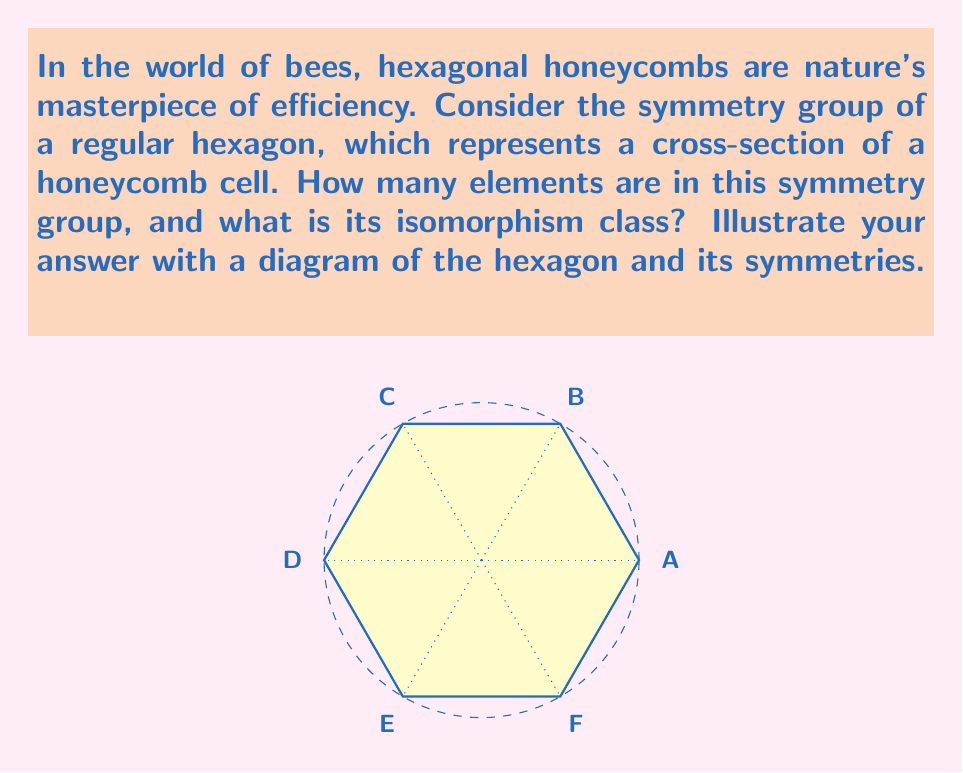Can you solve this math problem? To analyze the symmetry group of a regular hexagon, we need to consider all the transformations that leave the hexagon unchanged. Let's break this down step-by-step:

1) Rotational symmetries:
   - The hexagon can be rotated by 60°, 120°, 180°, 240°, 300°, and 360° (identity).
   - This gives us 6 rotational symmetries.

2) Reflection symmetries:
   - There are 6 lines of reflection: 3 through opposite vertices and 3 through the midpoints of opposite sides.
   - This gives us 6 reflection symmetries.

3) Total number of symmetries:
   - The total number of elements in the symmetry group is the sum of rotational and reflection symmetries.
   - 6 + 6 = 12 elements

4) Group structure:
   - This group is known as the dihedral group of order 12, denoted as $D_6$ or $D_{12}$.
   - It is generated by a rotation $r$ of 60° and a reflection $s$.
   - The group has the presentation: $\langle r,s | r^6 = s^2 = 1, srs = r^{-1} \rangle$

5) Isomorphism class:
   - The symmetry group of a regular hexagon is isomorphic to $D_6$ (or $D_{12}$).
   - It is not isomorphic to the cyclic group $C_{12}$ because it is non-abelian.

6) Group elements:
   - Identity: $e$
   - Rotations: $r, r^2, r^3, r^4, r^5$
   - Reflections: $s, sr, sr^2, sr^3, sr^4, sr^5$

The diagram illustrates the axes of symmetry (dotted lines for rotations, dashed lines for reflections) of the hexagon.
Answer: 12 elements; isomorphic to $D_6$ (or $D_{12}$) 